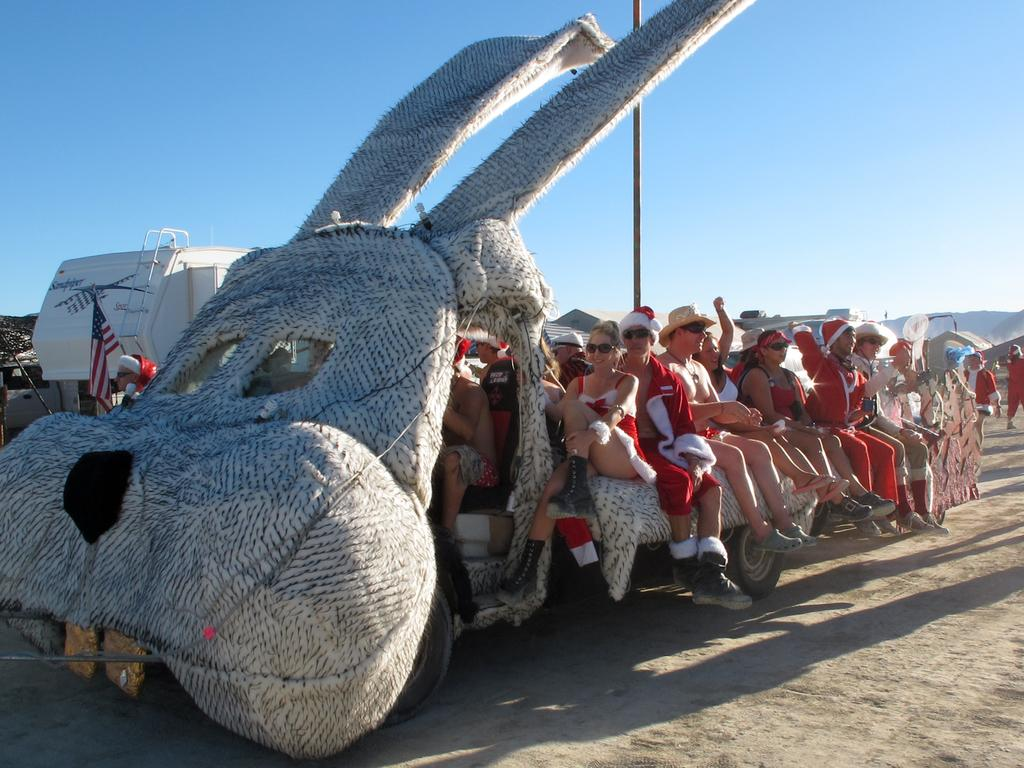Who is present in the image? There are people in the image. What are the people doing in the image? The people are sitting in a vehicle. How is the vehicle in the image different from a regular vehicle? The vehicle is decorated. What type of glass is being used to protect the people from the crow in the image? There is no crow or glass present in the image. 